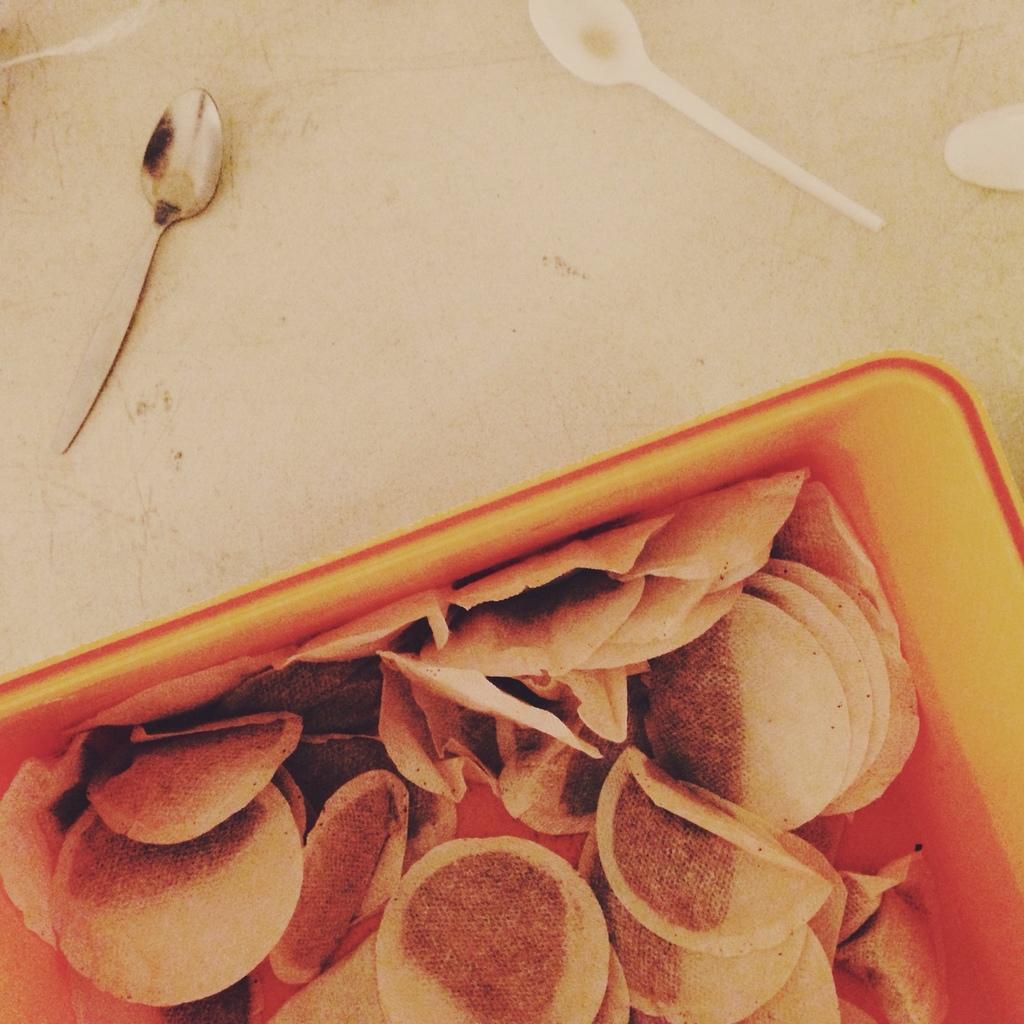Please provide a concise description of this image. In the bottom we can see some food item. On the top we can see three spoons on the table. 